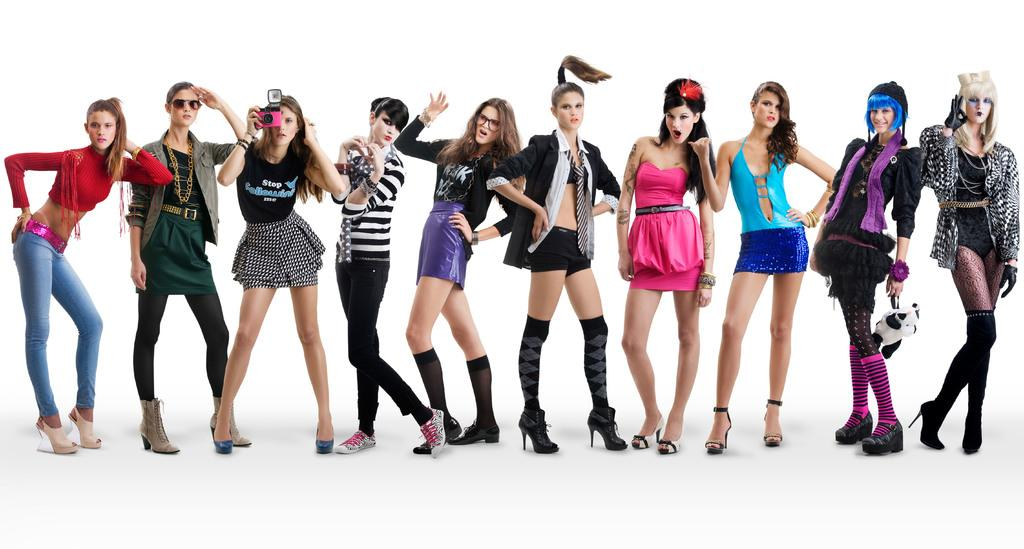What is happening in the image? There is a group of people standing in the image. What are some of the people holding in their hands? Some people are holding objects in their hands. What color is the background of the image? The background of the image is white. How many ducks are sitting on the knee of the person in the image? There are no ducks present in the image, and no one is shown with a knee. 